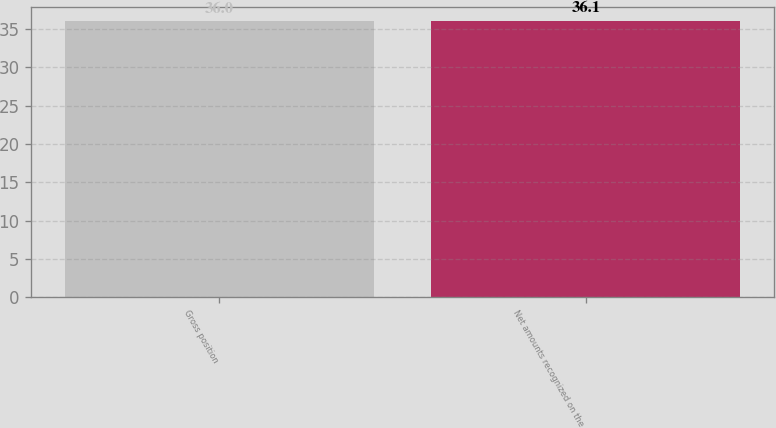Convert chart. <chart><loc_0><loc_0><loc_500><loc_500><bar_chart><fcel>Gross position<fcel>Net amounts recognized on the<nl><fcel>36<fcel>36.1<nl></chart> 